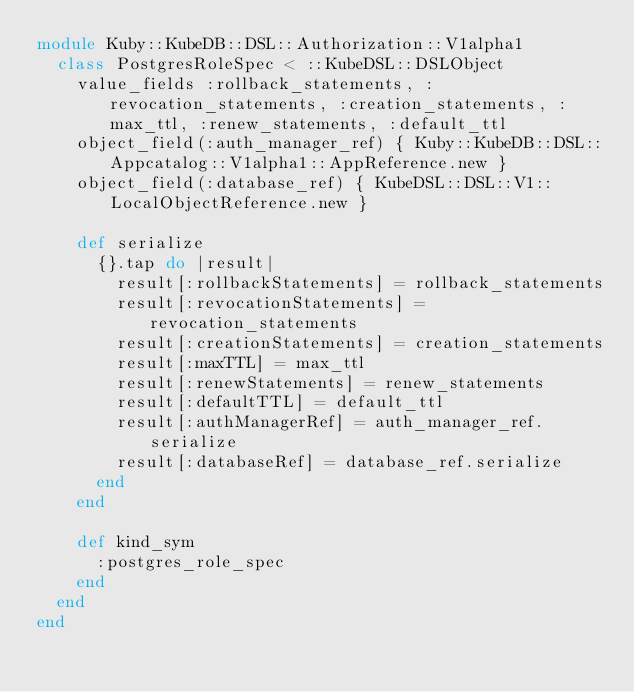<code> <loc_0><loc_0><loc_500><loc_500><_Ruby_>module Kuby::KubeDB::DSL::Authorization::V1alpha1
  class PostgresRoleSpec < ::KubeDSL::DSLObject
    value_fields :rollback_statements, :revocation_statements, :creation_statements, :max_ttl, :renew_statements, :default_ttl
    object_field(:auth_manager_ref) { Kuby::KubeDB::DSL::Appcatalog::V1alpha1::AppReference.new }
    object_field(:database_ref) { KubeDSL::DSL::V1::LocalObjectReference.new }

    def serialize
      {}.tap do |result|
        result[:rollbackStatements] = rollback_statements
        result[:revocationStatements] = revocation_statements
        result[:creationStatements] = creation_statements
        result[:maxTTL] = max_ttl
        result[:renewStatements] = renew_statements
        result[:defaultTTL] = default_ttl
        result[:authManagerRef] = auth_manager_ref.serialize
        result[:databaseRef] = database_ref.serialize
      end
    end

    def kind_sym
      :postgres_role_spec
    end
  end
end
</code> 